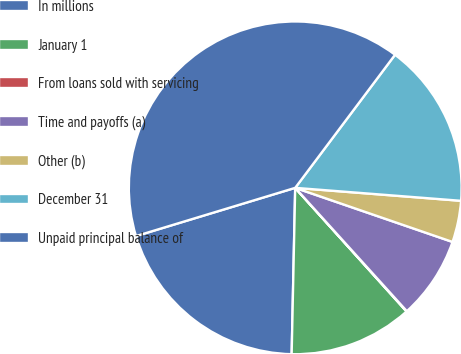<chart> <loc_0><loc_0><loc_500><loc_500><pie_chart><fcel>In millions<fcel>January 1<fcel>From loans sold with servicing<fcel>Time and payoffs (a)<fcel>Other (b)<fcel>December 31<fcel>Unpaid principal balance of<nl><fcel>19.98%<fcel>12.01%<fcel>0.04%<fcel>8.02%<fcel>4.03%<fcel>16.0%<fcel>39.93%<nl></chart> 